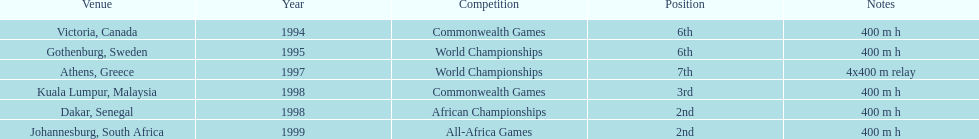Other than 1999, what year did ken harnden win second place? 1998. 